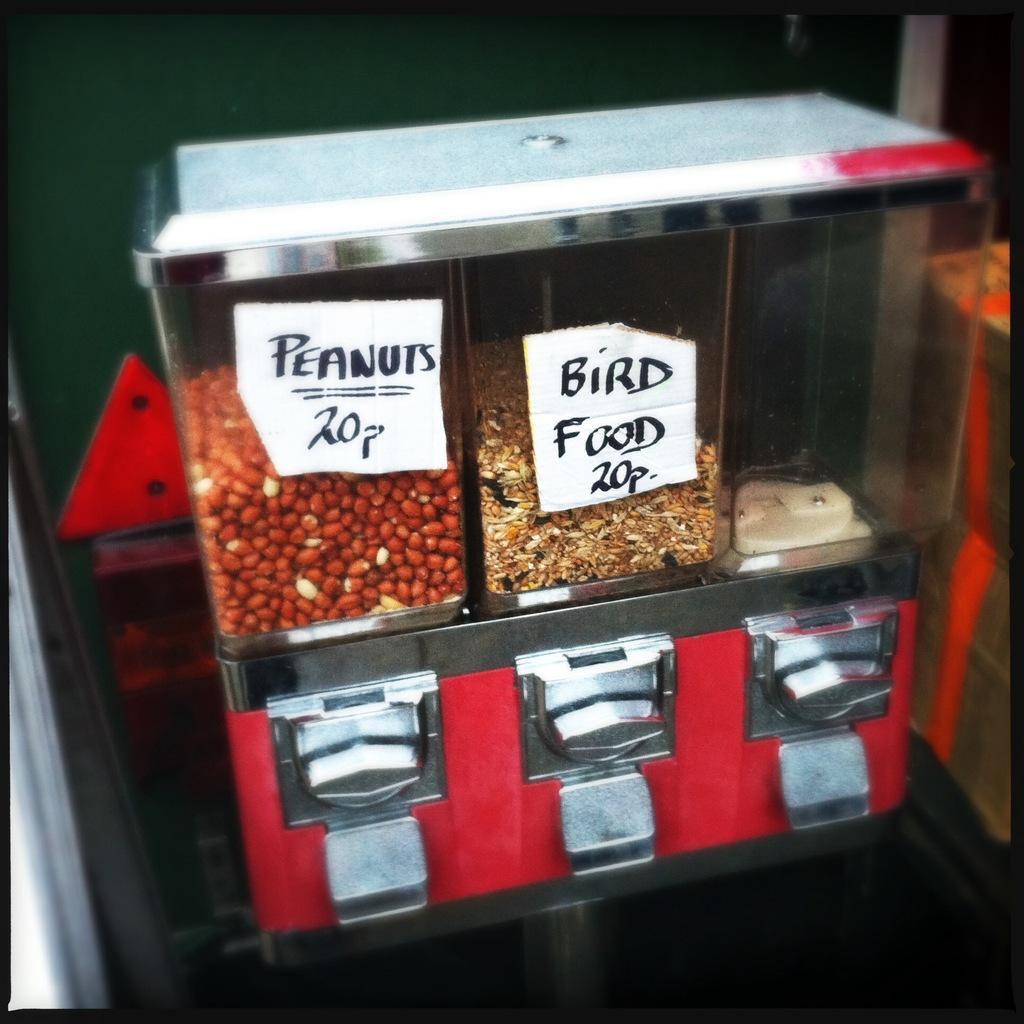Please provide a concise description of this image. In this image I can see peanuts, bird food in the glass bowl. 